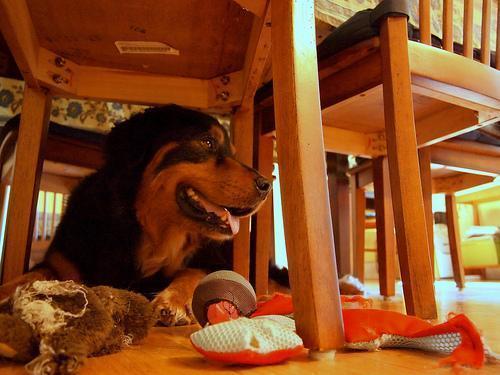How many dogs are there?
Give a very brief answer. 1. 